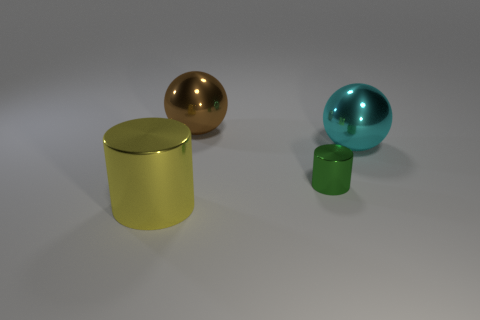How many small metal objects are in front of the brown metallic sphere?
Offer a very short reply. 1. How big is the cyan metallic ball?
Provide a short and direct response. Large. The cylinder that is made of the same material as the green object is what color?
Provide a short and direct response. Yellow. What number of other brown balls have the same size as the brown metallic ball?
Provide a short and direct response. 0. Do the cylinder behind the large yellow thing and the cyan ball have the same material?
Offer a terse response. Yes. Are there fewer large cylinders that are in front of the green metal thing than cyan objects?
Offer a very short reply. No. What shape is the big shiny object that is in front of the big cyan ball?
Your answer should be very brief. Cylinder. What shape is the brown thing that is the same size as the yellow metal cylinder?
Give a very brief answer. Sphere. Is there a matte object that has the same shape as the big yellow metallic thing?
Give a very brief answer. No. There is a thing on the right side of the small metallic object; does it have the same shape as the shiny object that is behind the big cyan shiny thing?
Your answer should be very brief. Yes. 